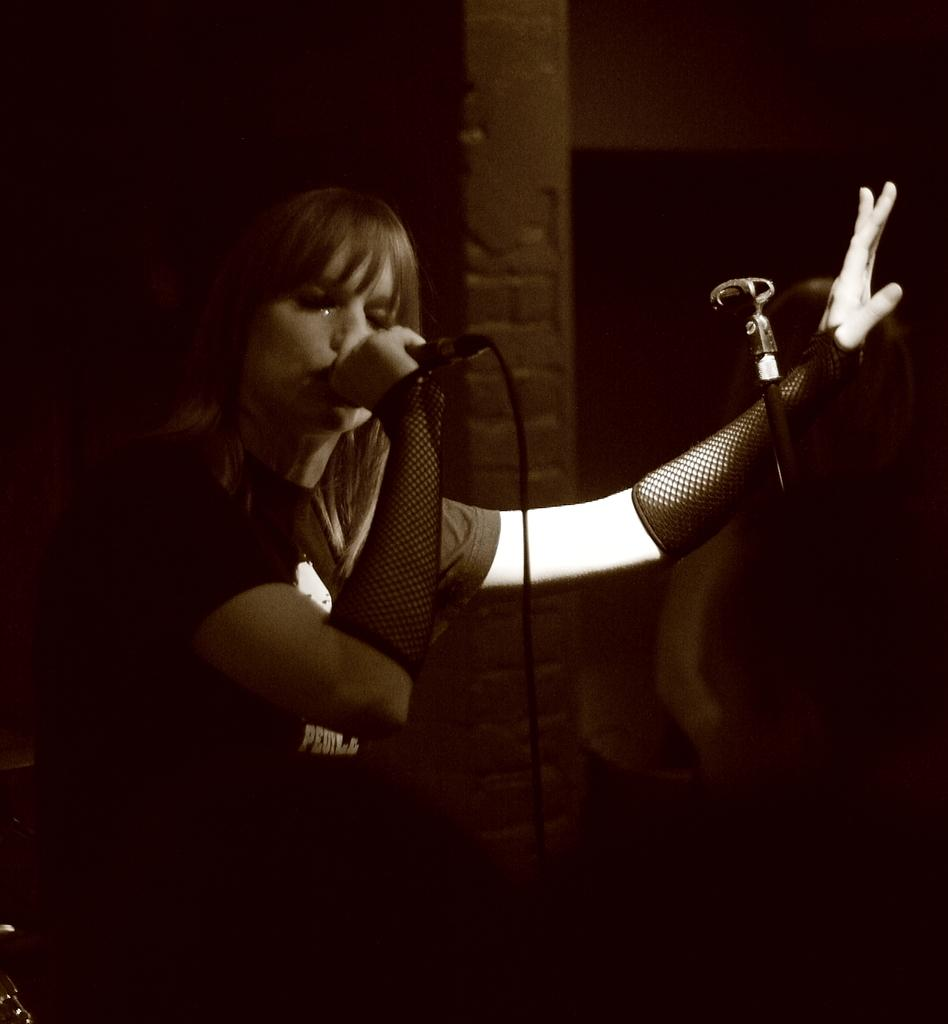What is the overall tone or lighting of the image? The image is dark. What is the woman in the image doing? The woman is sitting and singing into a microphone. What can be seen in the background of the image? There is a wall in the background of the image. How many crates are stacked on the table in the image? There are no crates present in the image. What type of meal is being prepared in the image? There is no meal preparation visible in the image. 